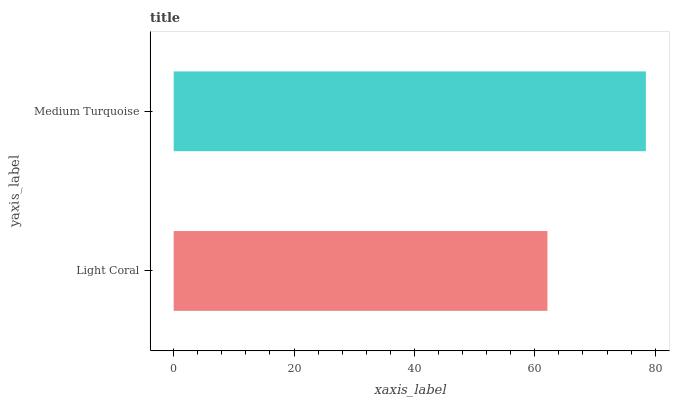Is Light Coral the minimum?
Answer yes or no. Yes. Is Medium Turquoise the maximum?
Answer yes or no. Yes. Is Medium Turquoise the minimum?
Answer yes or no. No. Is Medium Turquoise greater than Light Coral?
Answer yes or no. Yes. Is Light Coral less than Medium Turquoise?
Answer yes or no. Yes. Is Light Coral greater than Medium Turquoise?
Answer yes or no. No. Is Medium Turquoise less than Light Coral?
Answer yes or no. No. Is Medium Turquoise the high median?
Answer yes or no. Yes. Is Light Coral the low median?
Answer yes or no. Yes. Is Light Coral the high median?
Answer yes or no. No. Is Medium Turquoise the low median?
Answer yes or no. No. 